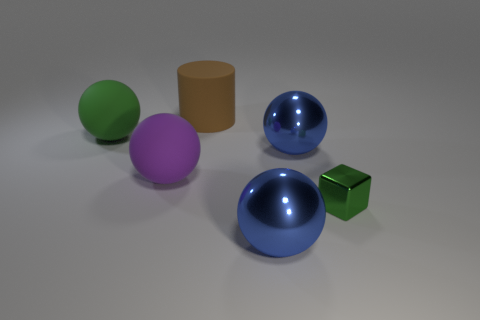What is the shape of the purple matte thing?
Keep it short and to the point. Sphere. Is there anything else that has the same material as the green sphere?
Your response must be concise. Yes. Do the brown object and the green sphere have the same material?
Make the answer very short. Yes. There is a big matte ball that is behind the blue object behind the big purple matte object; is there a large matte object right of it?
Keep it short and to the point. Yes. How many other things are there of the same shape as the purple object?
Offer a terse response. 3. The object that is left of the matte cylinder and on the right side of the green matte ball has what shape?
Your response must be concise. Sphere. There is a large metallic object behind the green object right of the green thing that is behind the small green metallic cube; what color is it?
Your answer should be compact. Blue. Is the number of big blue metallic spheres behind the purple thing greater than the number of purple matte things that are in front of the metallic block?
Offer a terse response. Yes. How many other things are the same size as the purple rubber object?
Your response must be concise. 4. There is a blue sphere behind the green thing that is to the right of the large brown cylinder; what is its material?
Provide a short and direct response. Metal. 